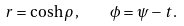Convert formula to latex. <formula><loc_0><loc_0><loc_500><loc_500>r = \cosh \rho \, , \quad \phi = \psi - t \, .</formula> 